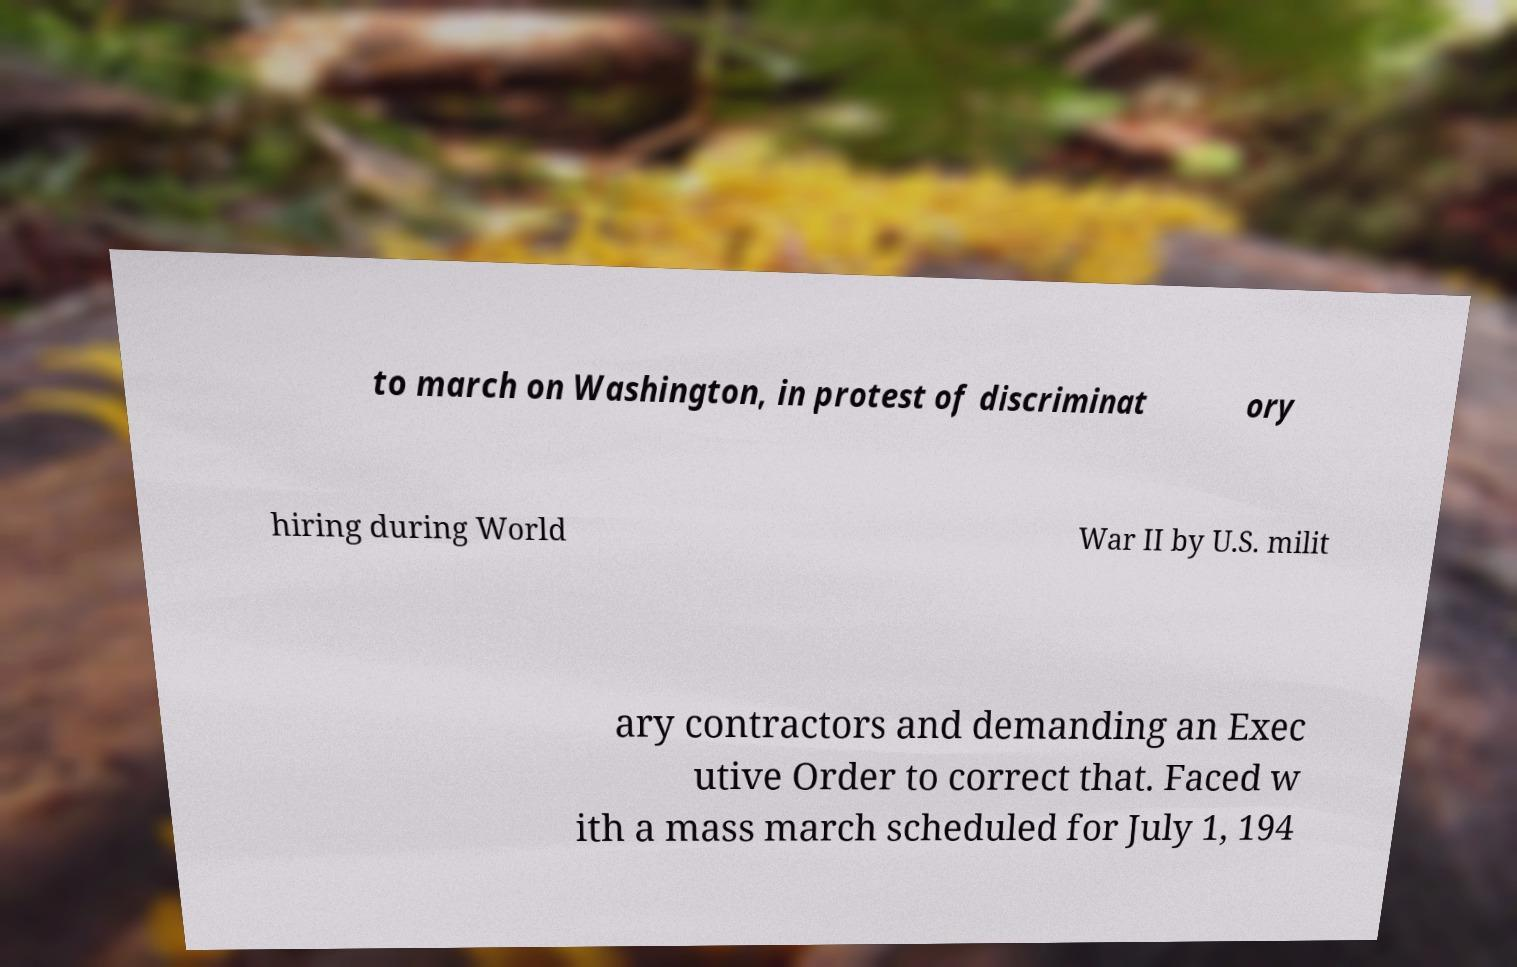Please identify and transcribe the text found in this image. to march on Washington, in protest of discriminat ory hiring during World War II by U.S. milit ary contractors and demanding an Exec utive Order to correct that. Faced w ith a mass march scheduled for July 1, 194 